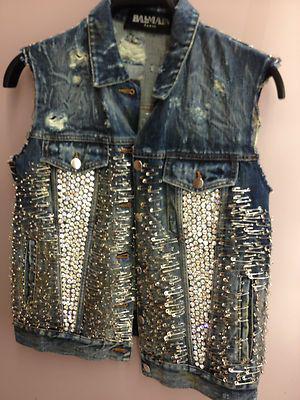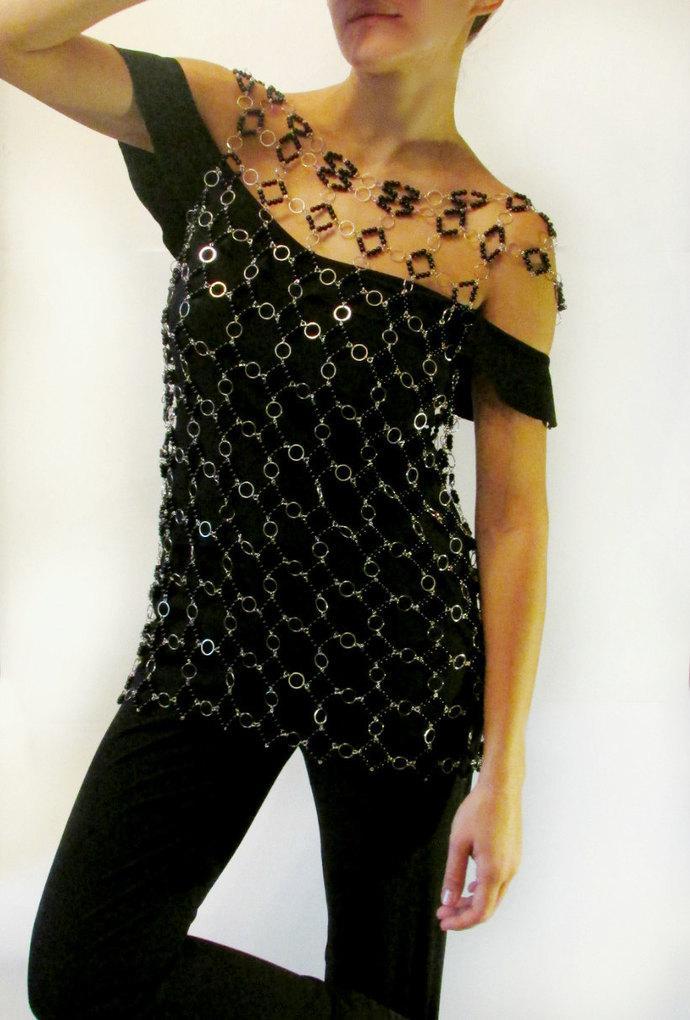The first image is the image on the left, the second image is the image on the right. For the images displayed, is the sentence "The jewelry in the image on the right is made from safety pins" factually correct? Answer yes or no. No. The first image is the image on the left, the second image is the image on the right. For the images displayed, is the sentence "An image features a jacket with an embellished studded lapel." factually correct? Answer yes or no. No. 